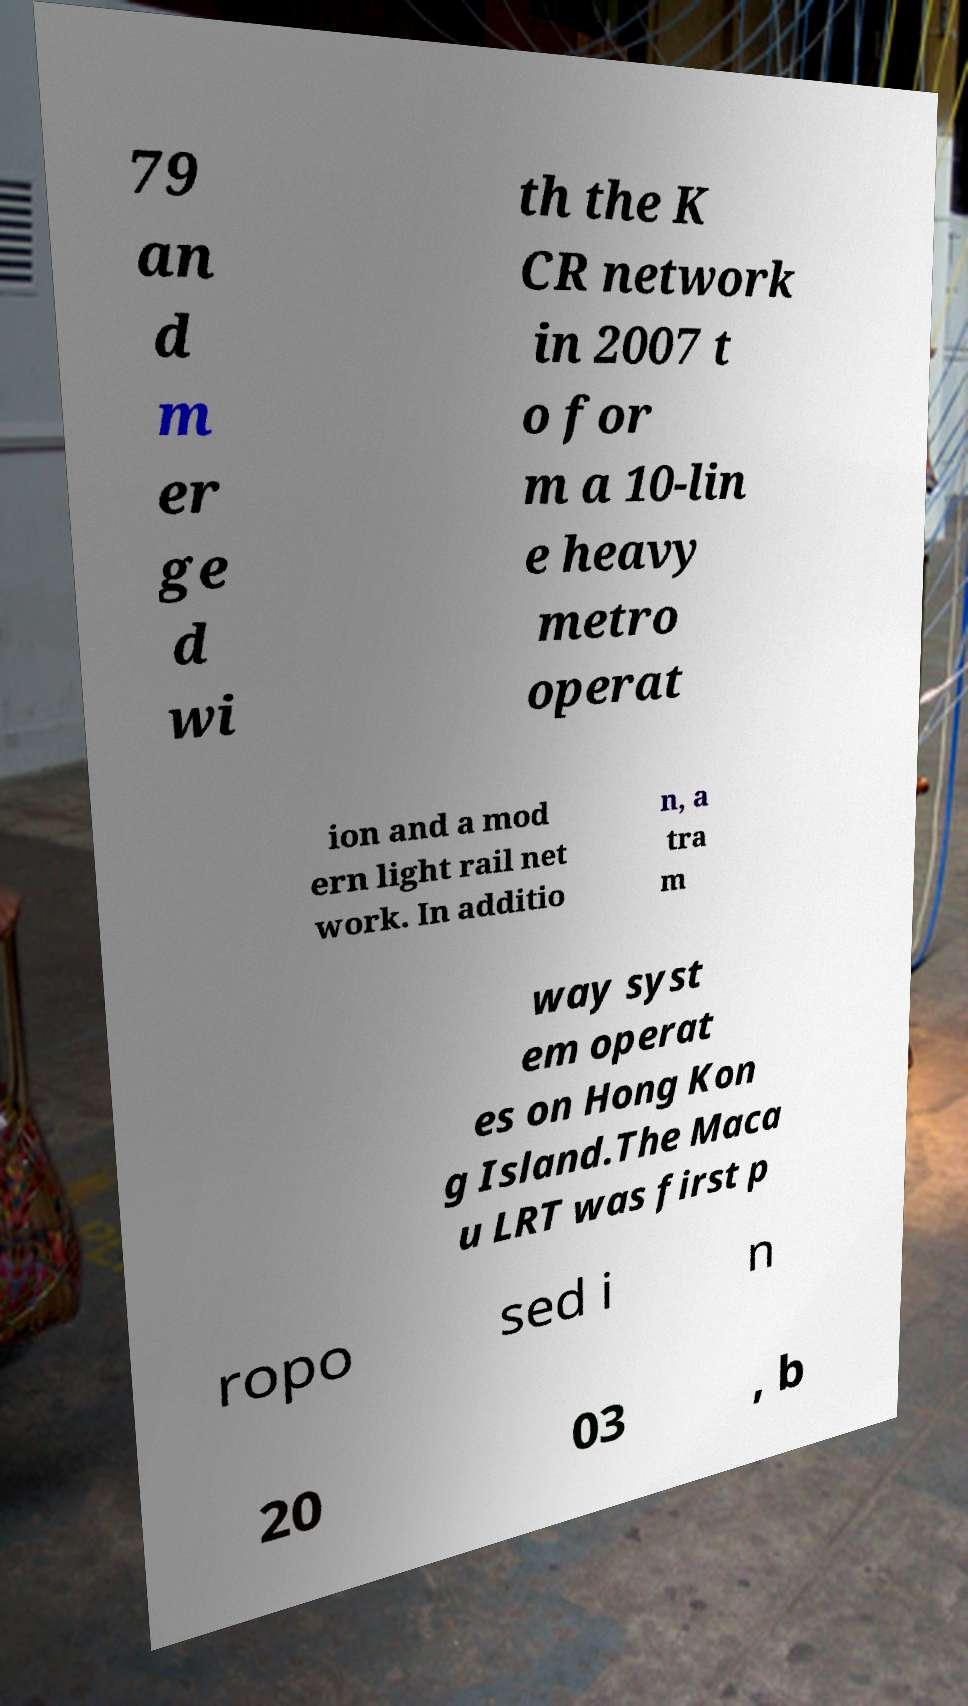Please read and relay the text visible in this image. What does it say? 79 an d m er ge d wi th the K CR network in 2007 t o for m a 10-lin e heavy metro operat ion and a mod ern light rail net work. In additio n, a tra m way syst em operat es on Hong Kon g Island.The Maca u LRT was first p ropo sed i n 20 03 , b 